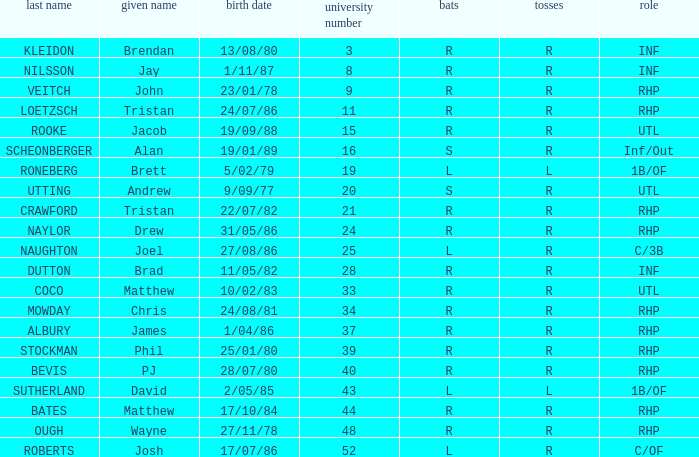Which Surname has Throws of l, and a DOB of 5/02/79? RONEBERG. 